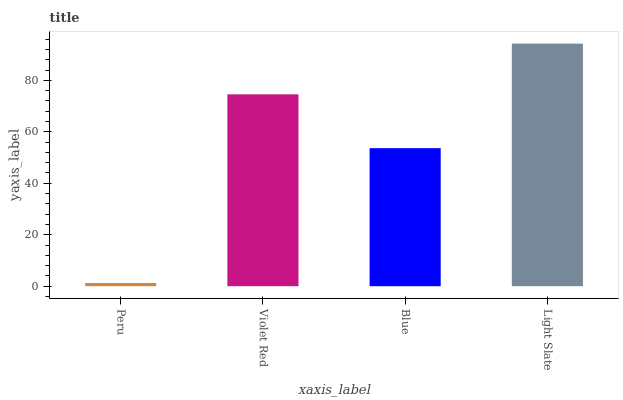Is Peru the minimum?
Answer yes or no. Yes. Is Light Slate the maximum?
Answer yes or no. Yes. Is Violet Red the minimum?
Answer yes or no. No. Is Violet Red the maximum?
Answer yes or no. No. Is Violet Red greater than Peru?
Answer yes or no. Yes. Is Peru less than Violet Red?
Answer yes or no. Yes. Is Peru greater than Violet Red?
Answer yes or no. No. Is Violet Red less than Peru?
Answer yes or no. No. Is Violet Red the high median?
Answer yes or no. Yes. Is Blue the low median?
Answer yes or no. Yes. Is Peru the high median?
Answer yes or no. No. Is Violet Red the low median?
Answer yes or no. No. 